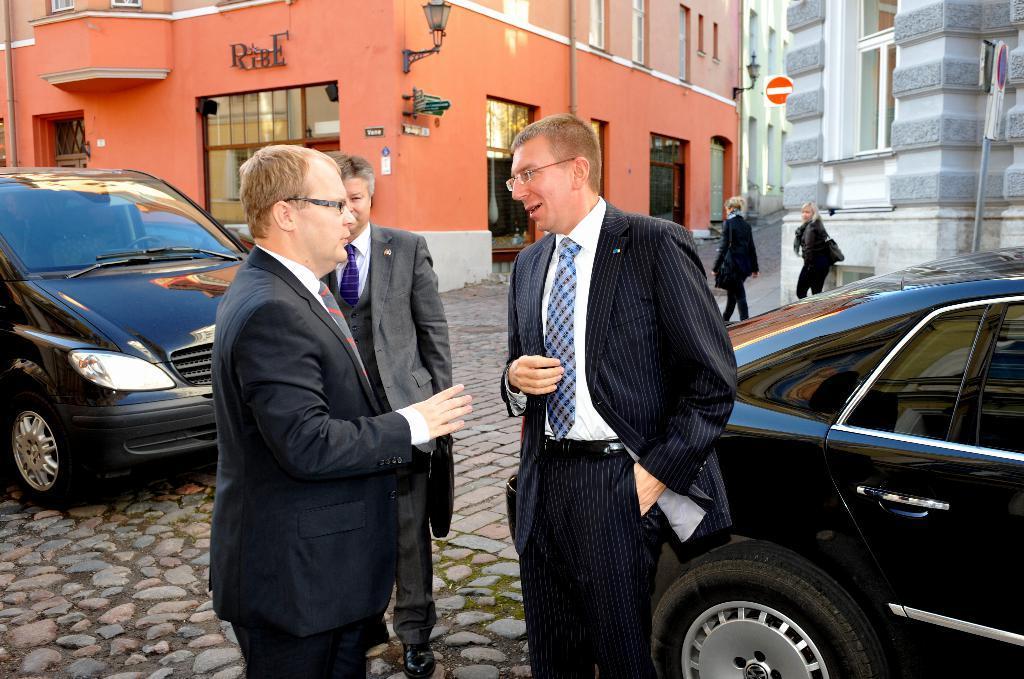How would you summarize this image in a sentence or two? In this image we can see three persons wearing the suits and standing on the land. We can also see two black color cars and two persons walking on the path. In the background we can see the buildings, sign board poles and also the lamps. At the bottom we can see the land with the stones. 